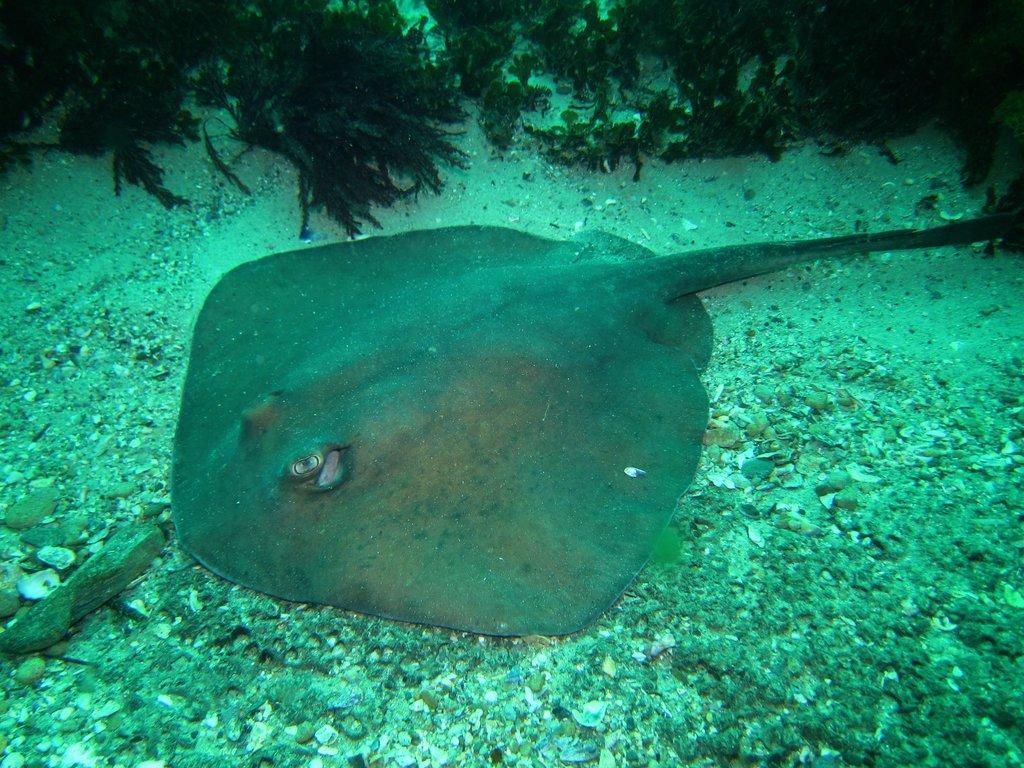How would you summarize this image in a sentence or two? In this picture we can see skate fish, stones and water plants under the water. 